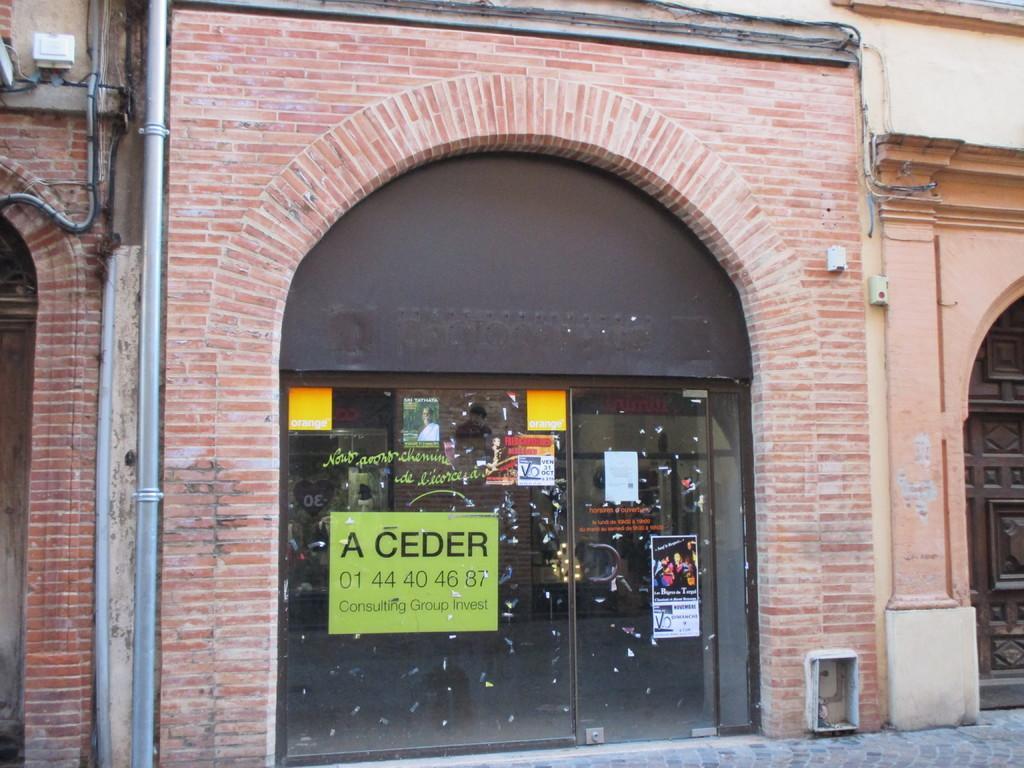Please provide a concise description of this image. In this image there is a wall having doors. Left side few pipes are attached to the wall. Few posters are attached to the glass door. Right bottom there is a cobblestone path. 